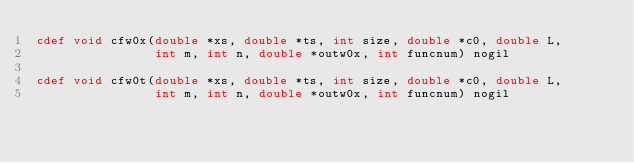Convert code to text. <code><loc_0><loc_0><loc_500><loc_500><_Cython_>cdef void cfw0x(double *xs, double *ts, int size, double *c0, double L,
                int m, int n, double *outw0x, int funcnum) nogil

cdef void cfw0t(double *xs, double *ts, int size, double *c0, double L,
                int m, int n, double *outw0x, int funcnum) nogil
</code> 